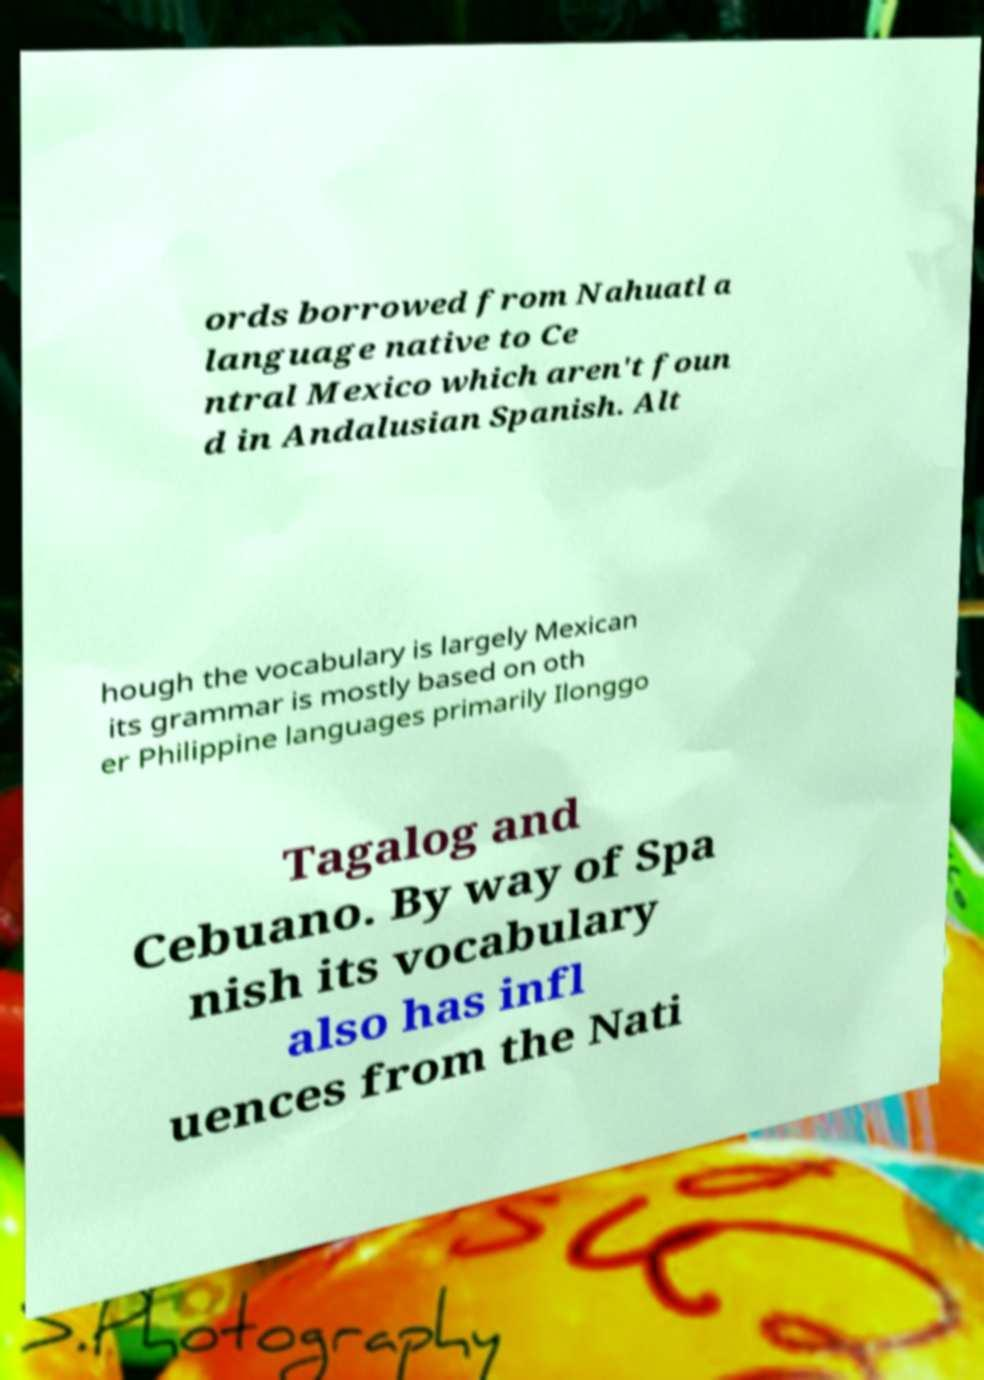For documentation purposes, I need the text within this image transcribed. Could you provide that? ords borrowed from Nahuatl a language native to Ce ntral Mexico which aren't foun d in Andalusian Spanish. Alt hough the vocabulary is largely Mexican its grammar is mostly based on oth er Philippine languages primarily Ilonggo Tagalog and Cebuano. By way of Spa nish its vocabulary also has infl uences from the Nati 